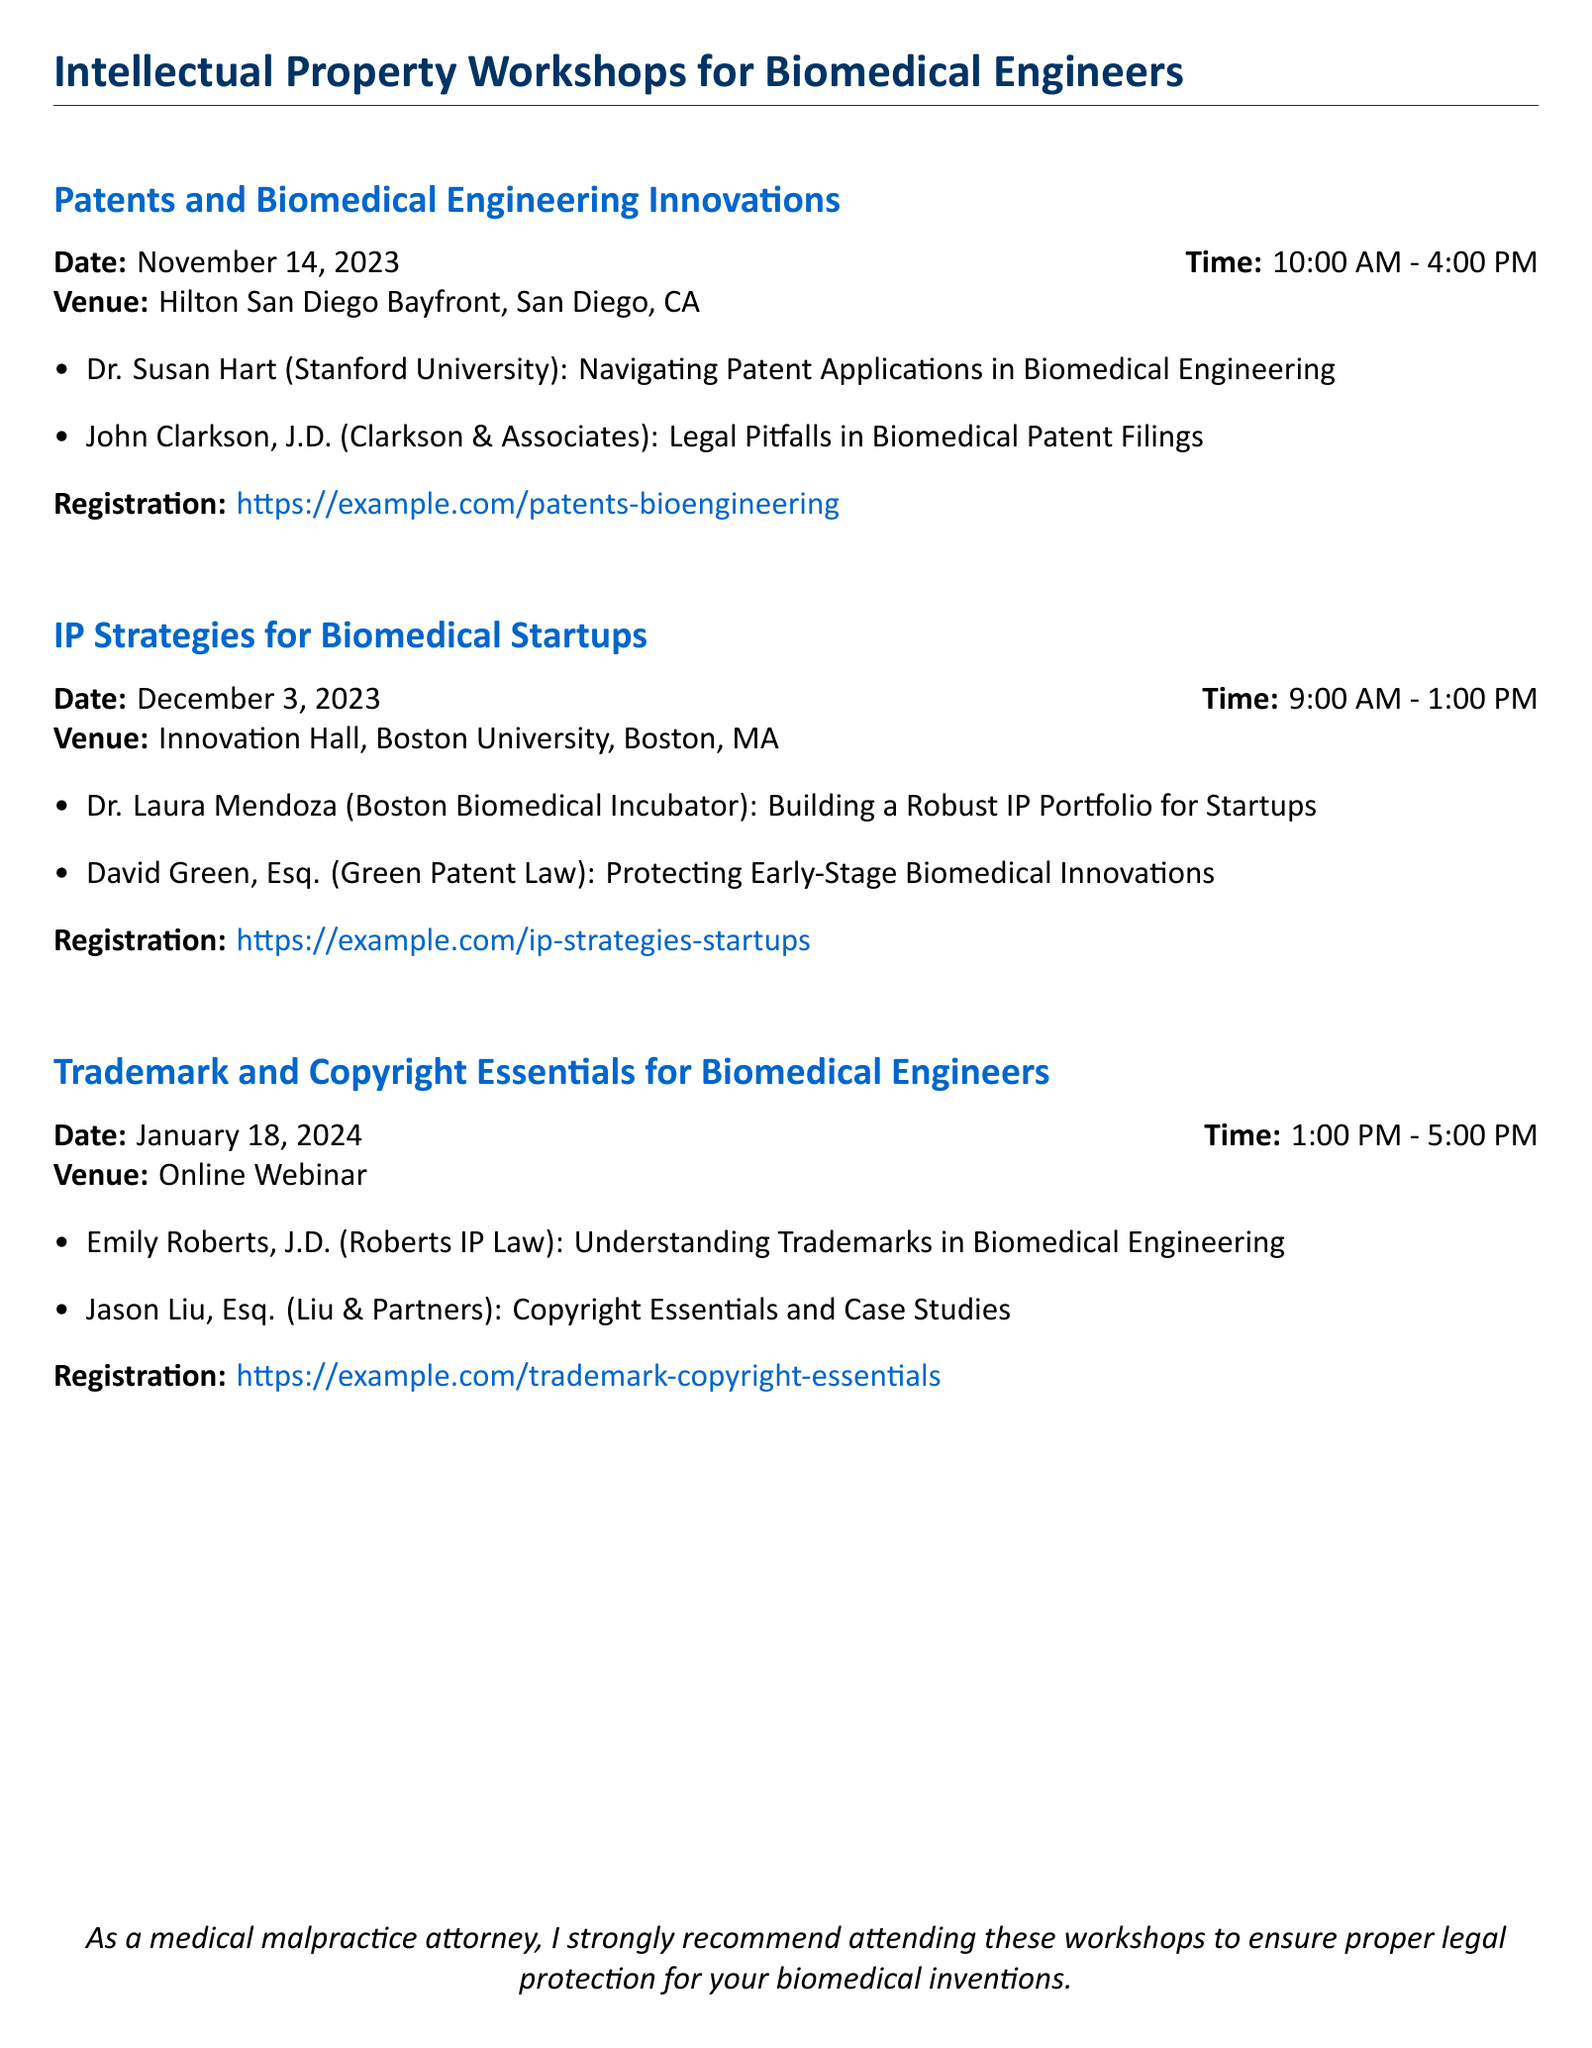What is the date of the Patents workshop? The date for the Patents and Biomedical Engineering Innovations workshop is mentioned clearly in the document.
Answer: November 14, 2023 Who is speaking about legal pitfalls in biomedical patent filings? The document lists the speakers and their topics, identifying John Clarkson as the speaker on this topic.
Answer: John Clarkson, J.D What time does the IP Strategies workshop start? The start time for the IP Strategies for Biomedical Startups workshop is provided in the document.
Answer: 9:00 AM Where is the Trademark and Copyright Essentials workshop held? The document specifies the venue for the respective workshop clearly, which is an important detail for attendees.
Answer: Online Webinar What is the registration link for the Patents workshop? The document contains the registration link specifically for the Patents and Biomedical Engineering Innovations workshop.
Answer: https://example.com/patents-bioengineering Who is the speaker discussing trademarks in biomedical engineering? The document highlights the speakers associated with each topic, stating Emily Roberts is addressing this topic.
Answer: Emily Roberts, J.D How long is the Trademark and Copyright Essentials workshop? The duration of workshops is specified in the document and provides important information for planning.
Answer: 4 hours What is highlighted as a recommendation for attendees? The concluding statement of the document emphasizes the importance of attending the workshops for legal protection.
Answer: Proper legal protection for your biomedical inventions 